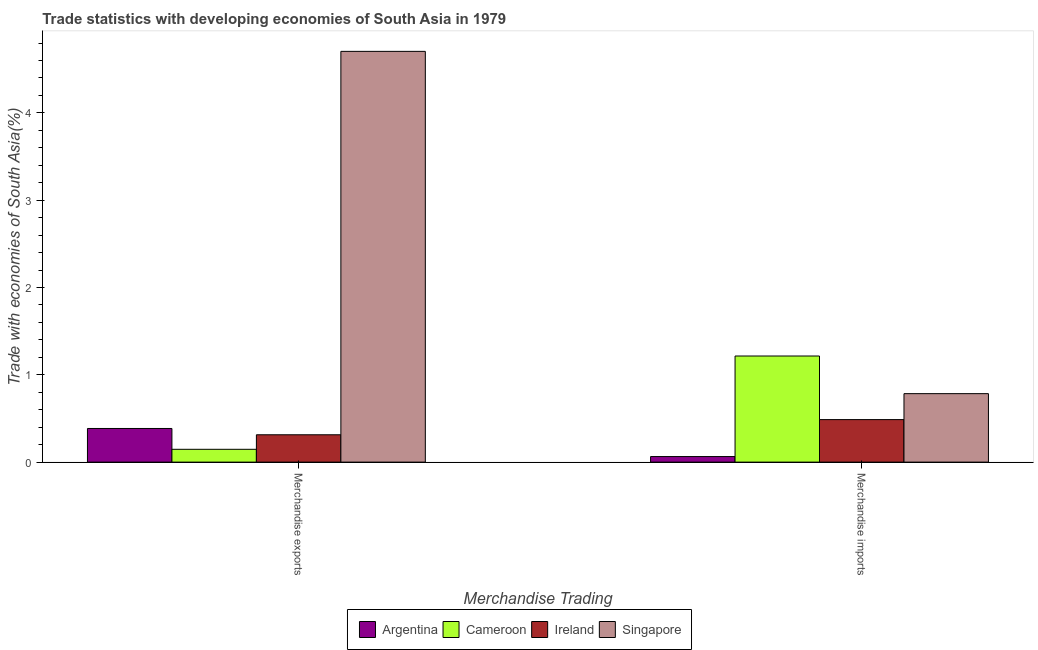How many different coloured bars are there?
Ensure brevity in your answer.  4. Are the number of bars per tick equal to the number of legend labels?
Make the answer very short. Yes. Are the number of bars on each tick of the X-axis equal?
Give a very brief answer. Yes. How many bars are there on the 1st tick from the right?
Your answer should be very brief. 4. What is the label of the 1st group of bars from the left?
Offer a very short reply. Merchandise exports. What is the merchandise imports in Ireland?
Your answer should be compact. 0.49. Across all countries, what is the maximum merchandise imports?
Ensure brevity in your answer.  1.22. Across all countries, what is the minimum merchandise imports?
Provide a short and direct response. 0.06. In which country was the merchandise imports maximum?
Your answer should be very brief. Cameroon. In which country was the merchandise exports minimum?
Your answer should be compact. Cameroon. What is the total merchandise exports in the graph?
Make the answer very short. 5.55. What is the difference between the merchandise imports in Cameroon and that in Singapore?
Your response must be concise. 0.43. What is the difference between the merchandise imports in Ireland and the merchandise exports in Singapore?
Your response must be concise. -4.22. What is the average merchandise imports per country?
Ensure brevity in your answer.  0.64. What is the difference between the merchandise imports and merchandise exports in Cameroon?
Give a very brief answer. 1.07. What is the ratio of the merchandise imports in Singapore to that in Cameroon?
Offer a very short reply. 0.65. In how many countries, is the merchandise imports greater than the average merchandise imports taken over all countries?
Give a very brief answer. 2. What does the 2nd bar from the left in Merchandise exports represents?
Your answer should be compact. Cameroon. What does the 1st bar from the right in Merchandise imports represents?
Offer a very short reply. Singapore. How many bars are there?
Your answer should be very brief. 8. Are the values on the major ticks of Y-axis written in scientific E-notation?
Offer a very short reply. No. Does the graph contain any zero values?
Provide a short and direct response. No. Where does the legend appear in the graph?
Offer a terse response. Bottom center. How many legend labels are there?
Provide a short and direct response. 4. How are the legend labels stacked?
Keep it short and to the point. Horizontal. What is the title of the graph?
Your answer should be compact. Trade statistics with developing economies of South Asia in 1979. What is the label or title of the X-axis?
Give a very brief answer. Merchandise Trading. What is the label or title of the Y-axis?
Your response must be concise. Trade with economies of South Asia(%). What is the Trade with economies of South Asia(%) in Argentina in Merchandise exports?
Offer a terse response. 0.39. What is the Trade with economies of South Asia(%) of Cameroon in Merchandise exports?
Your answer should be very brief. 0.15. What is the Trade with economies of South Asia(%) of Ireland in Merchandise exports?
Offer a terse response. 0.31. What is the Trade with economies of South Asia(%) of Singapore in Merchandise exports?
Make the answer very short. 4.7. What is the Trade with economies of South Asia(%) in Argentina in Merchandise imports?
Give a very brief answer. 0.06. What is the Trade with economies of South Asia(%) in Cameroon in Merchandise imports?
Give a very brief answer. 1.22. What is the Trade with economies of South Asia(%) in Ireland in Merchandise imports?
Offer a very short reply. 0.49. What is the Trade with economies of South Asia(%) of Singapore in Merchandise imports?
Your answer should be compact. 0.78. Across all Merchandise Trading, what is the maximum Trade with economies of South Asia(%) of Argentina?
Keep it short and to the point. 0.39. Across all Merchandise Trading, what is the maximum Trade with economies of South Asia(%) in Cameroon?
Your response must be concise. 1.22. Across all Merchandise Trading, what is the maximum Trade with economies of South Asia(%) in Ireland?
Your answer should be very brief. 0.49. Across all Merchandise Trading, what is the maximum Trade with economies of South Asia(%) of Singapore?
Keep it short and to the point. 4.7. Across all Merchandise Trading, what is the minimum Trade with economies of South Asia(%) in Argentina?
Provide a succinct answer. 0.06. Across all Merchandise Trading, what is the minimum Trade with economies of South Asia(%) of Cameroon?
Your response must be concise. 0.15. Across all Merchandise Trading, what is the minimum Trade with economies of South Asia(%) of Ireland?
Offer a terse response. 0.31. Across all Merchandise Trading, what is the minimum Trade with economies of South Asia(%) of Singapore?
Keep it short and to the point. 0.78. What is the total Trade with economies of South Asia(%) of Argentina in the graph?
Provide a succinct answer. 0.45. What is the total Trade with economies of South Asia(%) of Cameroon in the graph?
Provide a succinct answer. 1.36. What is the total Trade with economies of South Asia(%) in Ireland in the graph?
Provide a succinct answer. 0.8. What is the total Trade with economies of South Asia(%) of Singapore in the graph?
Give a very brief answer. 5.49. What is the difference between the Trade with economies of South Asia(%) in Argentina in Merchandise exports and that in Merchandise imports?
Provide a succinct answer. 0.32. What is the difference between the Trade with economies of South Asia(%) of Cameroon in Merchandise exports and that in Merchandise imports?
Offer a terse response. -1.07. What is the difference between the Trade with economies of South Asia(%) of Ireland in Merchandise exports and that in Merchandise imports?
Give a very brief answer. -0.17. What is the difference between the Trade with economies of South Asia(%) of Singapore in Merchandise exports and that in Merchandise imports?
Make the answer very short. 3.92. What is the difference between the Trade with economies of South Asia(%) in Argentina in Merchandise exports and the Trade with economies of South Asia(%) in Cameroon in Merchandise imports?
Your answer should be compact. -0.83. What is the difference between the Trade with economies of South Asia(%) of Argentina in Merchandise exports and the Trade with economies of South Asia(%) of Ireland in Merchandise imports?
Make the answer very short. -0.1. What is the difference between the Trade with economies of South Asia(%) of Argentina in Merchandise exports and the Trade with economies of South Asia(%) of Singapore in Merchandise imports?
Ensure brevity in your answer.  -0.4. What is the difference between the Trade with economies of South Asia(%) in Cameroon in Merchandise exports and the Trade with economies of South Asia(%) in Ireland in Merchandise imports?
Keep it short and to the point. -0.34. What is the difference between the Trade with economies of South Asia(%) in Cameroon in Merchandise exports and the Trade with economies of South Asia(%) in Singapore in Merchandise imports?
Make the answer very short. -0.64. What is the difference between the Trade with economies of South Asia(%) of Ireland in Merchandise exports and the Trade with economies of South Asia(%) of Singapore in Merchandise imports?
Your answer should be compact. -0.47. What is the average Trade with economies of South Asia(%) of Argentina per Merchandise Trading?
Your answer should be compact. 0.22. What is the average Trade with economies of South Asia(%) of Cameroon per Merchandise Trading?
Offer a terse response. 0.68. What is the average Trade with economies of South Asia(%) in Ireland per Merchandise Trading?
Offer a terse response. 0.4. What is the average Trade with economies of South Asia(%) in Singapore per Merchandise Trading?
Offer a very short reply. 2.74. What is the difference between the Trade with economies of South Asia(%) in Argentina and Trade with economies of South Asia(%) in Cameroon in Merchandise exports?
Your answer should be very brief. 0.24. What is the difference between the Trade with economies of South Asia(%) in Argentina and Trade with economies of South Asia(%) in Ireland in Merchandise exports?
Keep it short and to the point. 0.07. What is the difference between the Trade with economies of South Asia(%) of Argentina and Trade with economies of South Asia(%) of Singapore in Merchandise exports?
Give a very brief answer. -4.32. What is the difference between the Trade with economies of South Asia(%) in Cameroon and Trade with economies of South Asia(%) in Ireland in Merchandise exports?
Keep it short and to the point. -0.17. What is the difference between the Trade with economies of South Asia(%) of Cameroon and Trade with economies of South Asia(%) of Singapore in Merchandise exports?
Your answer should be compact. -4.56. What is the difference between the Trade with economies of South Asia(%) of Ireland and Trade with economies of South Asia(%) of Singapore in Merchandise exports?
Your response must be concise. -4.39. What is the difference between the Trade with economies of South Asia(%) in Argentina and Trade with economies of South Asia(%) in Cameroon in Merchandise imports?
Keep it short and to the point. -1.15. What is the difference between the Trade with economies of South Asia(%) of Argentina and Trade with economies of South Asia(%) of Ireland in Merchandise imports?
Make the answer very short. -0.42. What is the difference between the Trade with economies of South Asia(%) of Argentina and Trade with economies of South Asia(%) of Singapore in Merchandise imports?
Ensure brevity in your answer.  -0.72. What is the difference between the Trade with economies of South Asia(%) in Cameroon and Trade with economies of South Asia(%) in Ireland in Merchandise imports?
Provide a short and direct response. 0.73. What is the difference between the Trade with economies of South Asia(%) of Cameroon and Trade with economies of South Asia(%) of Singapore in Merchandise imports?
Give a very brief answer. 0.43. What is the difference between the Trade with economies of South Asia(%) of Ireland and Trade with economies of South Asia(%) of Singapore in Merchandise imports?
Make the answer very short. -0.3. What is the ratio of the Trade with economies of South Asia(%) of Argentina in Merchandise exports to that in Merchandise imports?
Ensure brevity in your answer.  6.04. What is the ratio of the Trade with economies of South Asia(%) in Cameroon in Merchandise exports to that in Merchandise imports?
Your answer should be very brief. 0.12. What is the ratio of the Trade with economies of South Asia(%) of Ireland in Merchandise exports to that in Merchandise imports?
Keep it short and to the point. 0.64. What is the ratio of the Trade with economies of South Asia(%) of Singapore in Merchandise exports to that in Merchandise imports?
Offer a terse response. 6. What is the difference between the highest and the second highest Trade with economies of South Asia(%) of Argentina?
Your answer should be compact. 0.32. What is the difference between the highest and the second highest Trade with economies of South Asia(%) in Cameroon?
Give a very brief answer. 1.07. What is the difference between the highest and the second highest Trade with economies of South Asia(%) of Ireland?
Keep it short and to the point. 0.17. What is the difference between the highest and the second highest Trade with economies of South Asia(%) in Singapore?
Your answer should be very brief. 3.92. What is the difference between the highest and the lowest Trade with economies of South Asia(%) of Argentina?
Your answer should be very brief. 0.32. What is the difference between the highest and the lowest Trade with economies of South Asia(%) in Cameroon?
Your response must be concise. 1.07. What is the difference between the highest and the lowest Trade with economies of South Asia(%) of Ireland?
Offer a terse response. 0.17. What is the difference between the highest and the lowest Trade with economies of South Asia(%) of Singapore?
Provide a succinct answer. 3.92. 